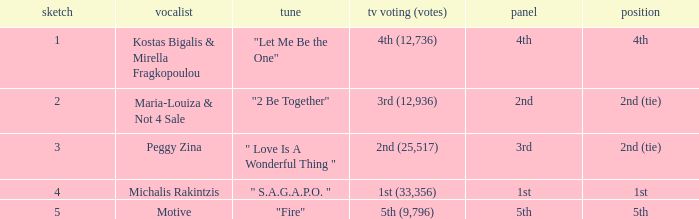Kostas Bigalis & Mirella Fragkopoulou the singer had what has the jury? 4th. 